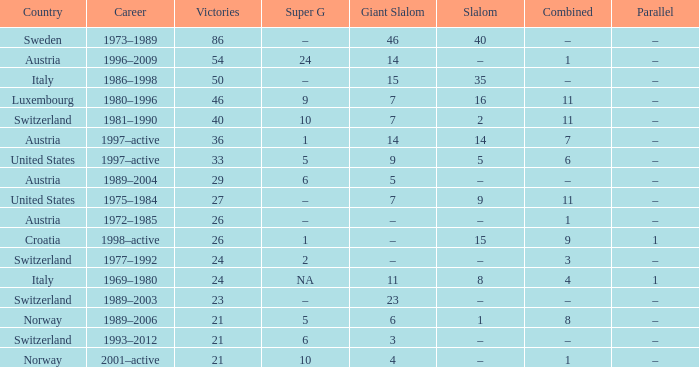What giant slalom boasts wins exceeding 27, a slalom of –, and a career covering 1996–2009? 14.0. 